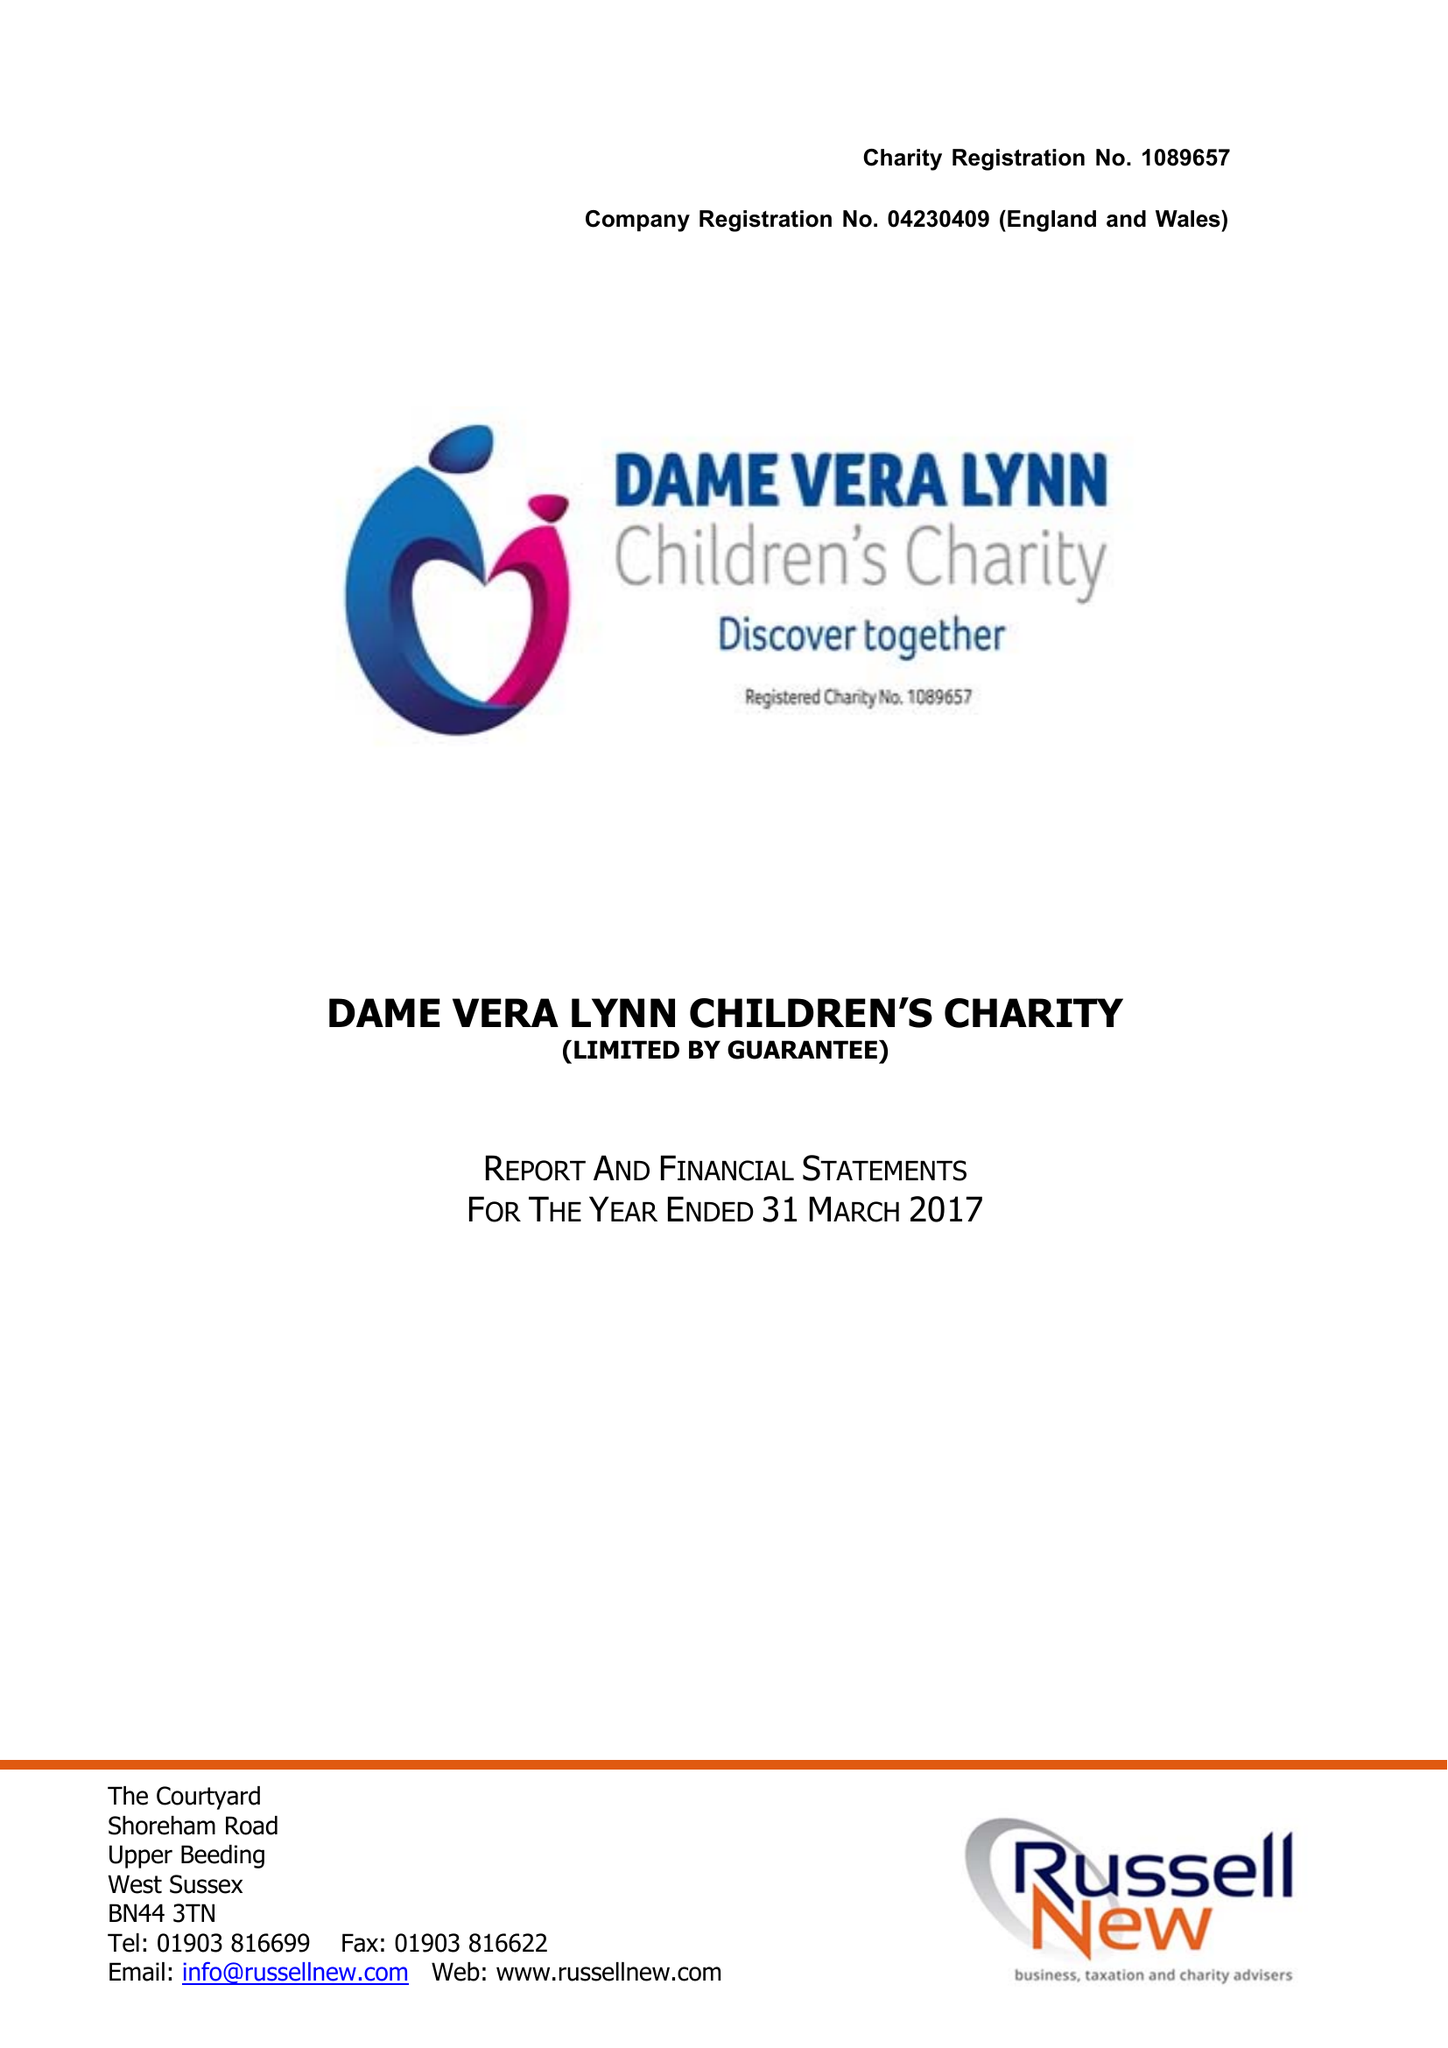What is the value for the address__post_town?
Answer the question using a single word or phrase. HAYWARDS HEATH 